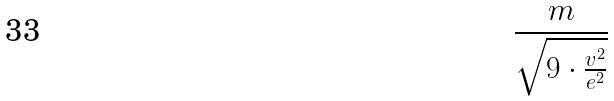Convert formula to latex. <formula><loc_0><loc_0><loc_500><loc_500>\frac { m } { \sqrt { 9 \cdot \frac { v ^ { 2 } } { e ^ { 2 } } } }</formula> 